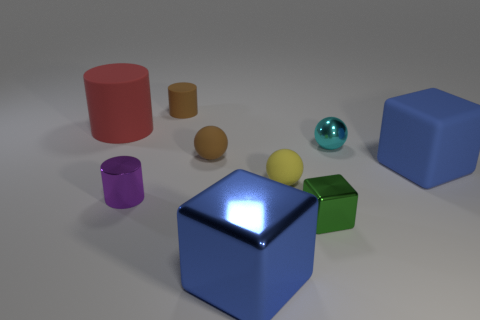How many objects are red shiny objects or small yellow things?
Your answer should be compact. 1. What size is the block behind the tiny cylinder in front of the brown thing behind the big red thing?
Give a very brief answer. Large. How many objects have the same color as the metal sphere?
Your answer should be compact. 0. What number of purple cylinders have the same material as the small cyan ball?
Give a very brief answer. 1. What number of things are tiny brown balls or things that are behind the green metallic object?
Ensure brevity in your answer.  7. What color is the large thing that is behind the sphere on the left side of the tiny matte object in front of the big blue matte cube?
Ensure brevity in your answer.  Red. There is a metal block that is behind the blue shiny cube; what size is it?
Offer a very short reply. Small. What number of large objects are red rubber cylinders or blue rubber cubes?
Provide a short and direct response. 2. There is a sphere that is both in front of the small cyan metal sphere and behind the yellow thing; what color is it?
Provide a short and direct response. Brown. Is there a big blue object of the same shape as the tiny green thing?
Your response must be concise. Yes. 